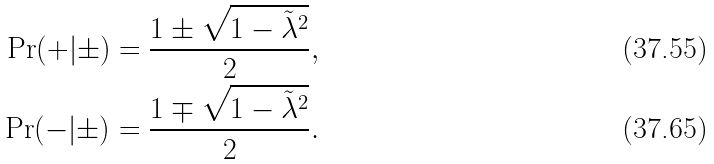<formula> <loc_0><loc_0><loc_500><loc_500>\Pr ( + | \pm ) & = \frac { 1 \pm \sqrt { 1 - \tilde { \lambda } ^ { 2 } } } { 2 } , \\ \Pr ( - | \pm ) & = \frac { 1 \mp \sqrt { 1 - \tilde { \lambda } ^ { 2 } } } { 2 } .</formula> 